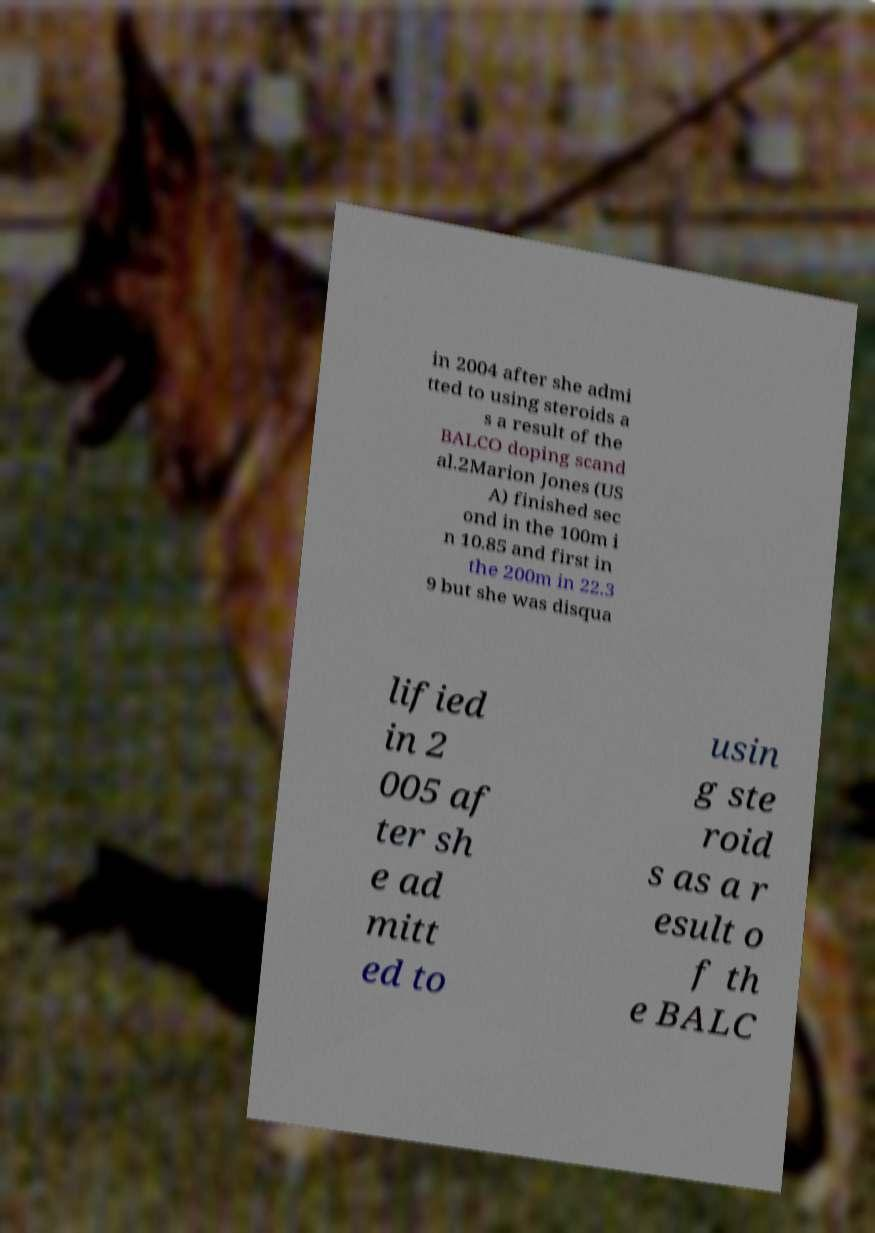For documentation purposes, I need the text within this image transcribed. Could you provide that? in 2004 after she admi tted to using steroids a s a result of the BALCO doping scand al.2Marion Jones (US A) finished sec ond in the 100m i n 10.85 and first in the 200m in 22.3 9 but she was disqua lified in 2 005 af ter sh e ad mitt ed to usin g ste roid s as a r esult o f th e BALC 